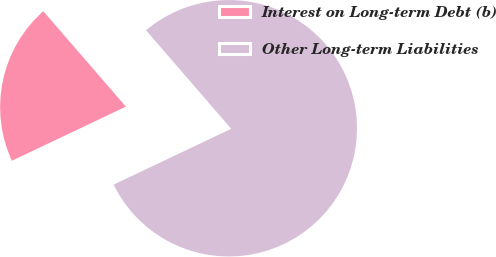<chart> <loc_0><loc_0><loc_500><loc_500><pie_chart><fcel>Interest on Long-term Debt (b)<fcel>Other Long-term Liabilities<nl><fcel>20.7%<fcel>79.3%<nl></chart> 